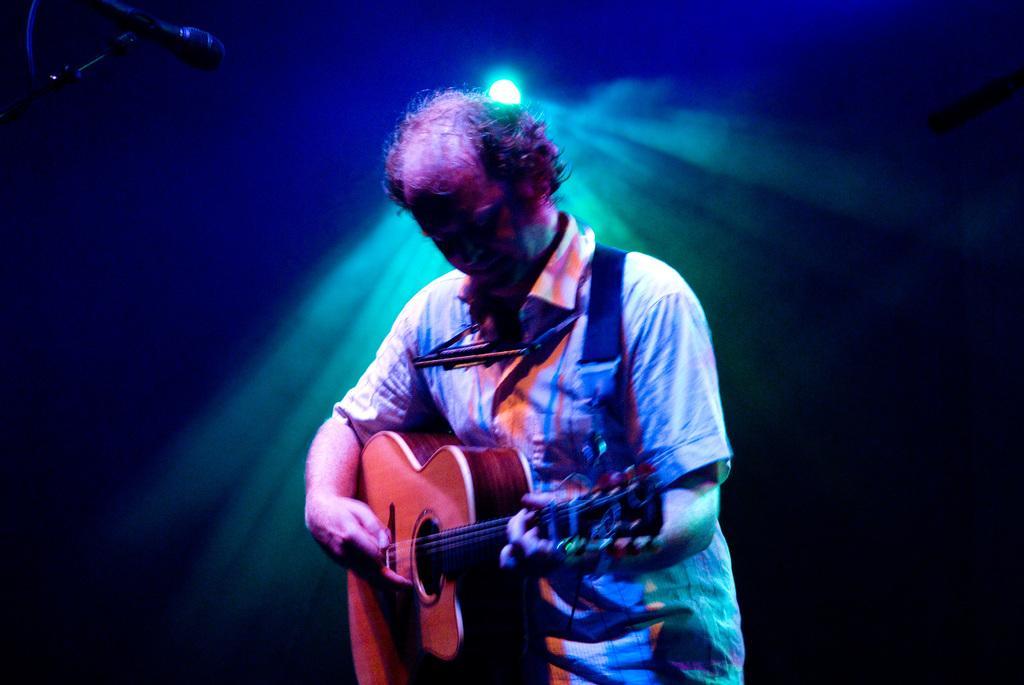In one or two sentences, can you explain what this image depicts? This picture shows a man playing guitar and we see a microphone here. 